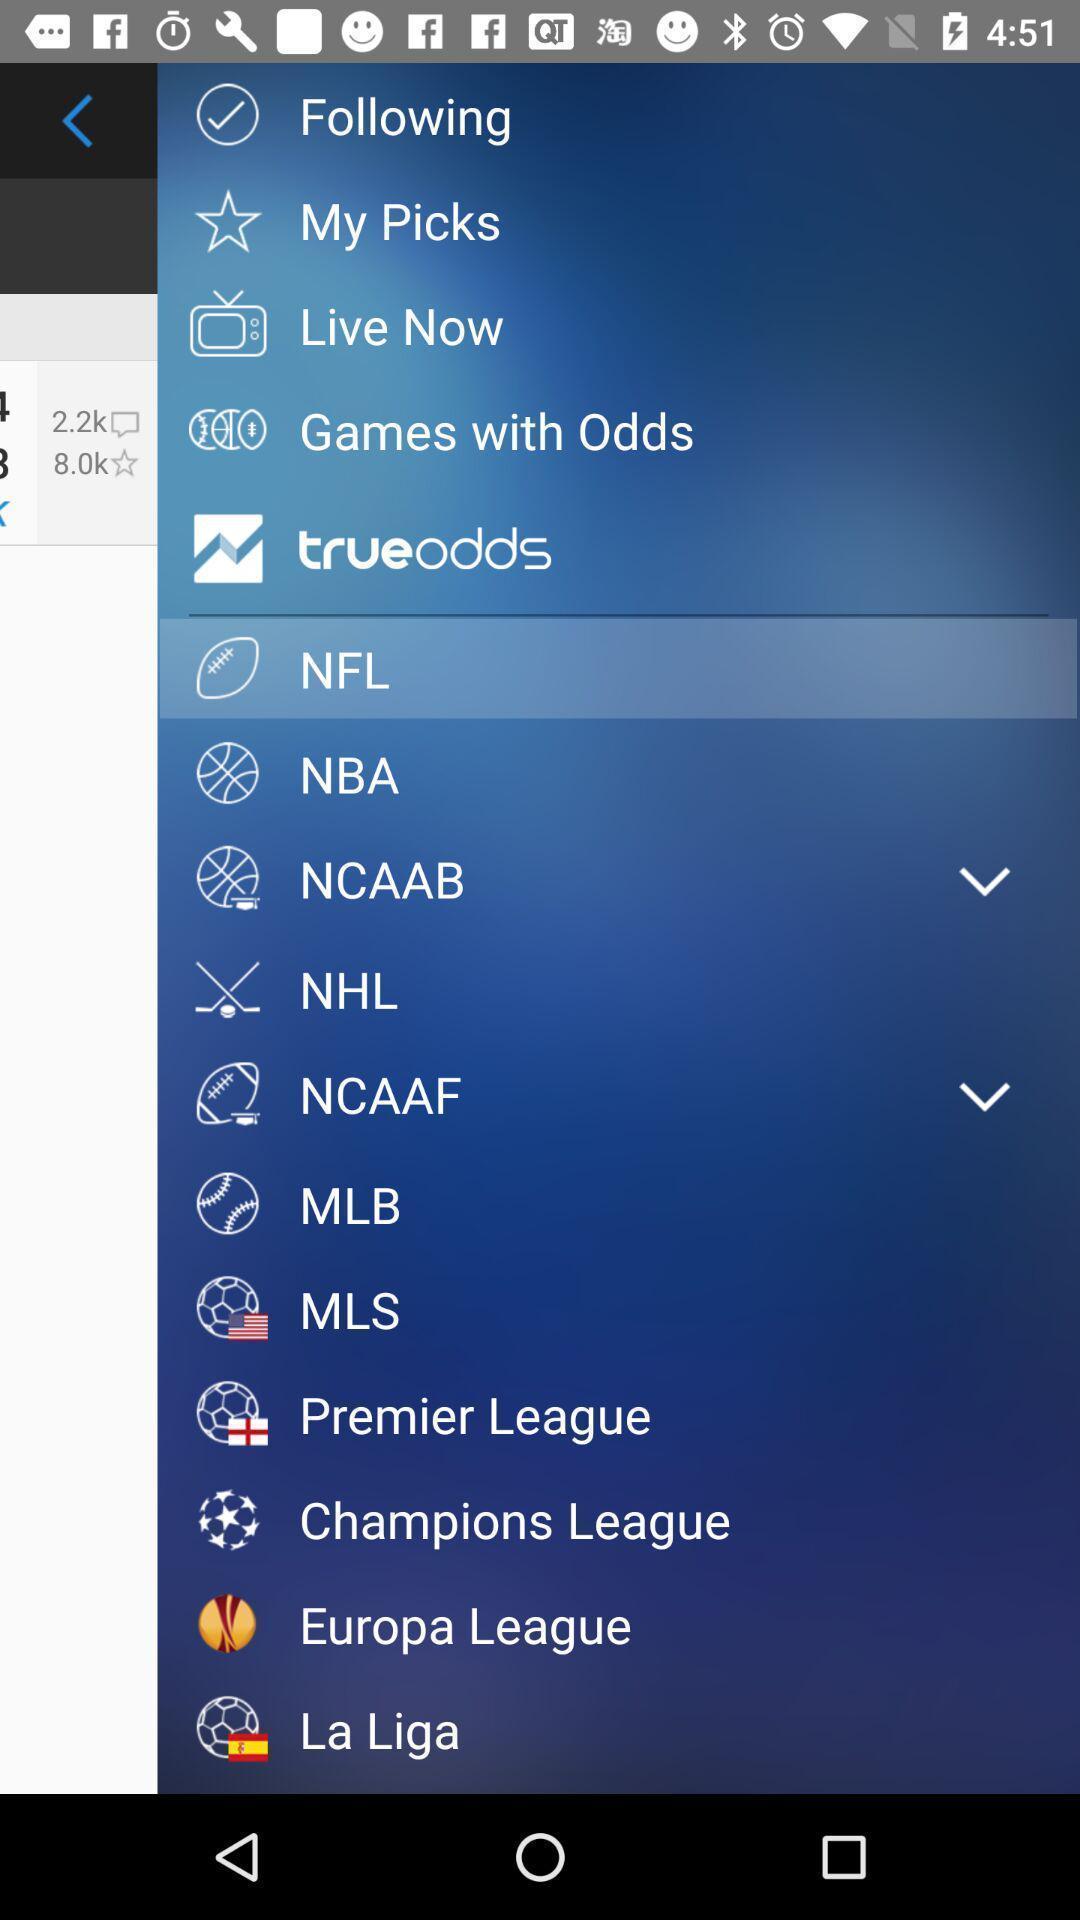Tell me what you see in this picture. Page showing variety of options of games. 